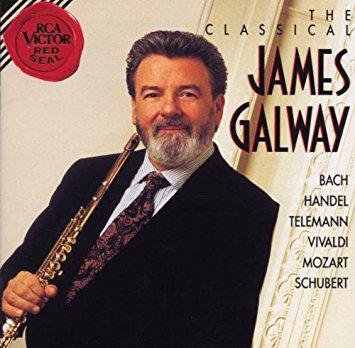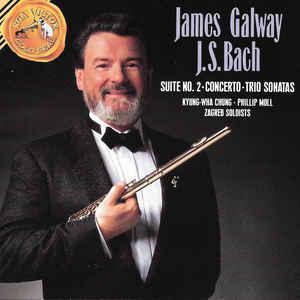The first image is the image on the left, the second image is the image on the right. Assess this claim about the two images: "An image shows a man with a gray beard in a dark suit, holding a flute up to his ear with the hand on the left.". Correct or not? Answer yes or no. Yes. The first image is the image on the left, the second image is the image on the right. Analyze the images presented: Is the assertion "At least one musician is playing the flute." valid? Answer yes or no. No. 